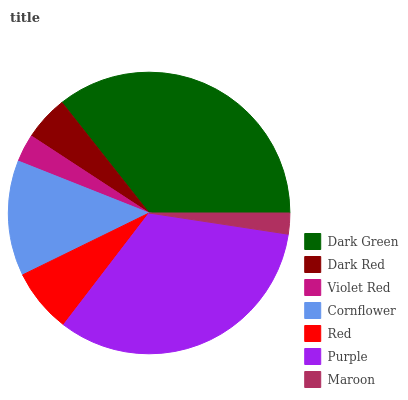Is Maroon the minimum?
Answer yes or no. Yes. Is Dark Green the maximum?
Answer yes or no. Yes. Is Dark Red the minimum?
Answer yes or no. No. Is Dark Red the maximum?
Answer yes or no. No. Is Dark Green greater than Dark Red?
Answer yes or no. Yes. Is Dark Red less than Dark Green?
Answer yes or no. Yes. Is Dark Red greater than Dark Green?
Answer yes or no. No. Is Dark Green less than Dark Red?
Answer yes or no. No. Is Red the high median?
Answer yes or no. Yes. Is Red the low median?
Answer yes or no. Yes. Is Dark Green the high median?
Answer yes or no. No. Is Violet Red the low median?
Answer yes or no. No. 